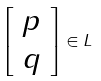<formula> <loc_0><loc_0><loc_500><loc_500>\left [ \begin{array} { c } p \\ q \end{array} \right ] \in L</formula> 